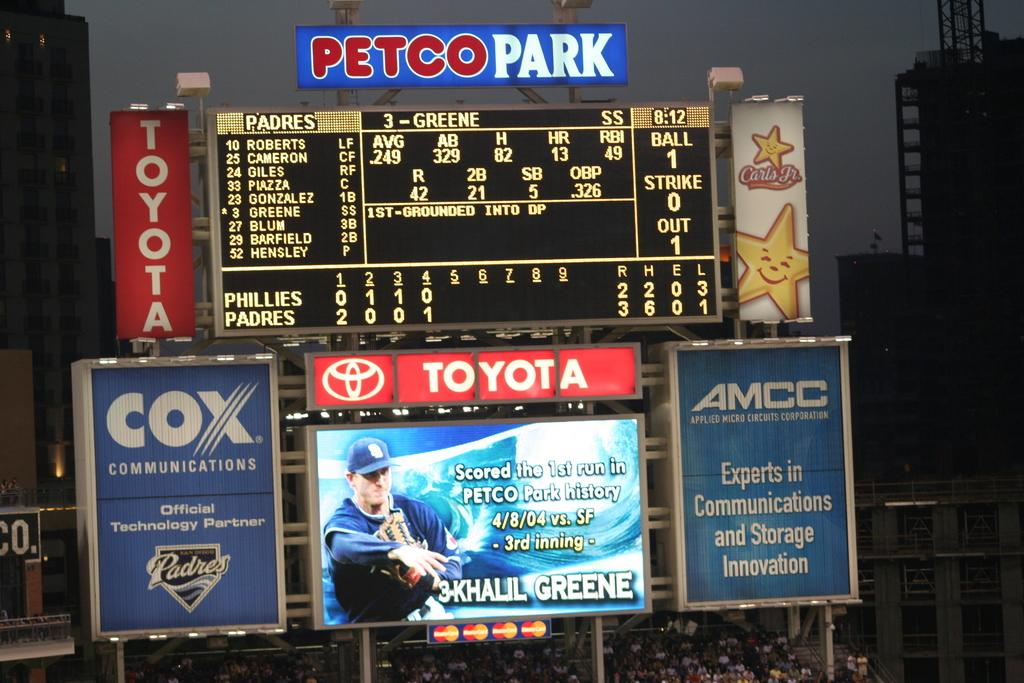<image>
Present a compact description of the photo's key features. a Toyota ad that is on a scoreboard 